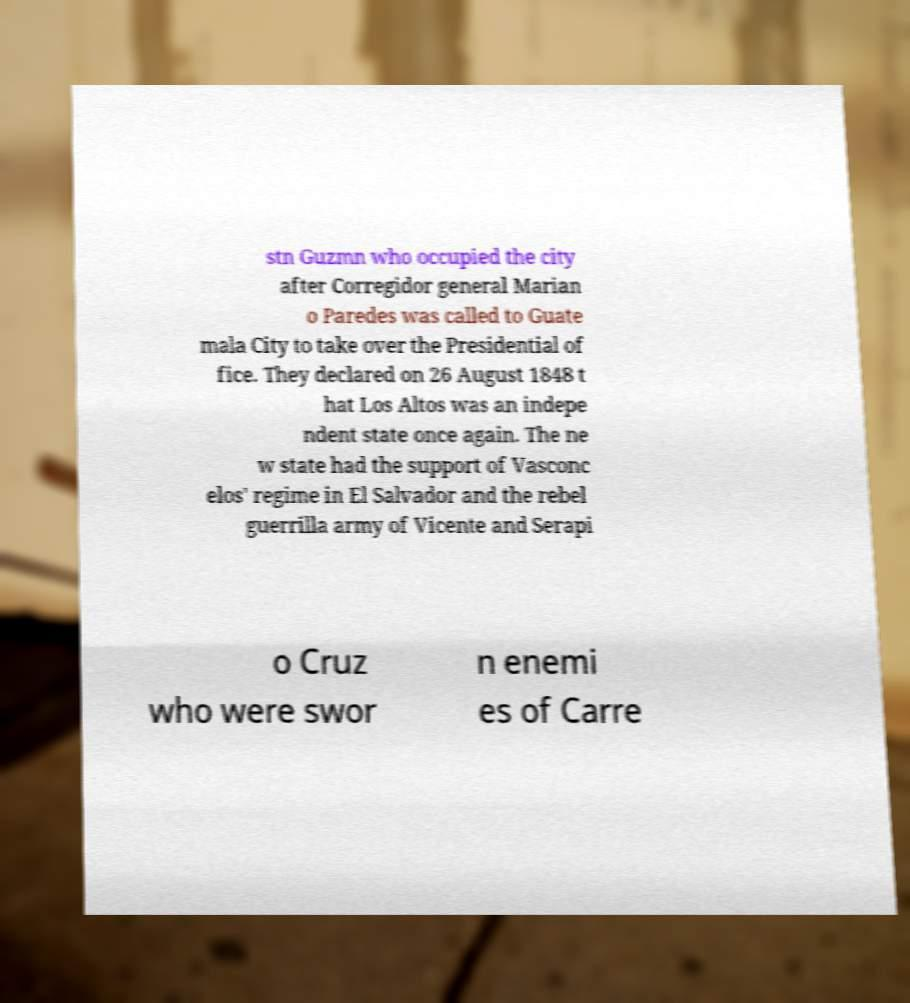There's text embedded in this image that I need extracted. Can you transcribe it verbatim? stn Guzmn who occupied the city after Corregidor general Marian o Paredes was called to Guate mala City to take over the Presidential of fice. They declared on 26 August 1848 t hat Los Altos was an indepe ndent state once again. The ne w state had the support of Vasconc elos' regime in El Salvador and the rebel guerrilla army of Vicente and Serapi o Cruz who were swor n enemi es of Carre 